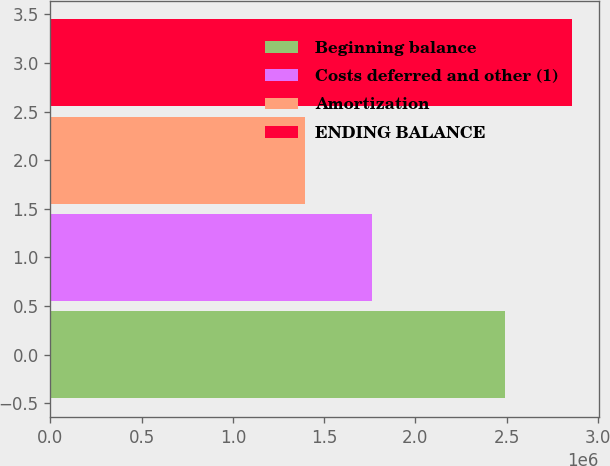Convert chart to OTSL. <chart><loc_0><loc_0><loc_500><loc_500><bar_chart><fcel>Beginning balance<fcel>Costs deferred and other (1)<fcel>Amortization<fcel>ENDING BALANCE<nl><fcel>2.49286e+06<fcel>1.76256e+06<fcel>1.39425e+06<fcel>2.86116e+06<nl></chart> 